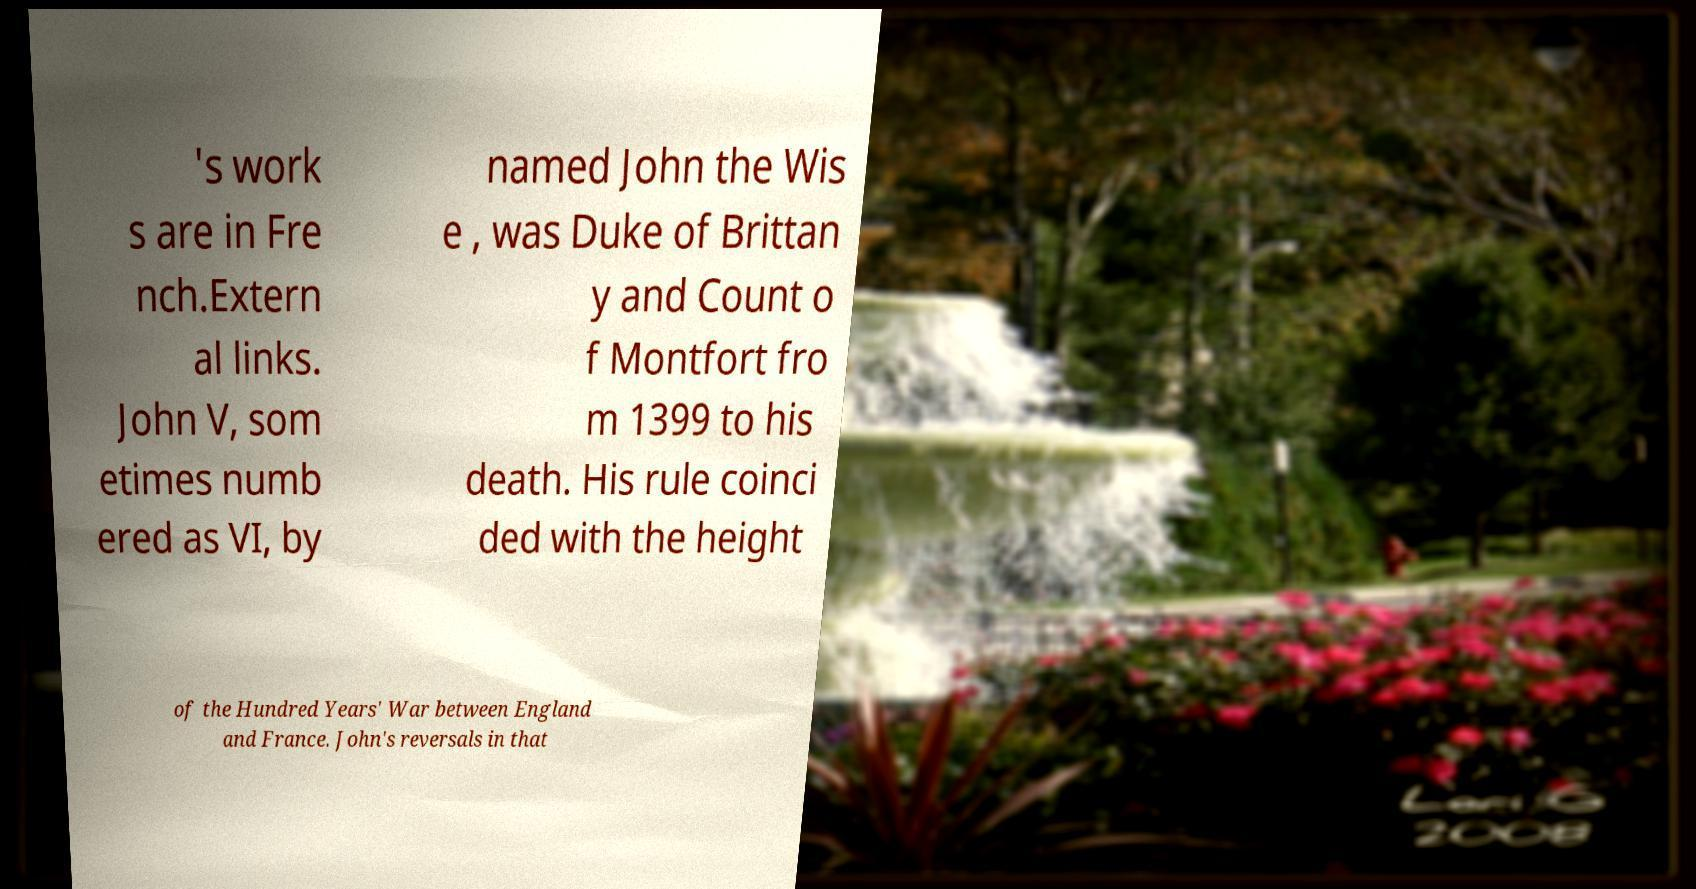Can you accurately transcribe the text from the provided image for me? 's work s are in Fre nch.Extern al links. John V, som etimes numb ered as VI, by named John the Wis e , was Duke of Brittan y and Count o f Montfort fro m 1399 to his death. His rule coinci ded with the height of the Hundred Years' War between England and France. John's reversals in that 